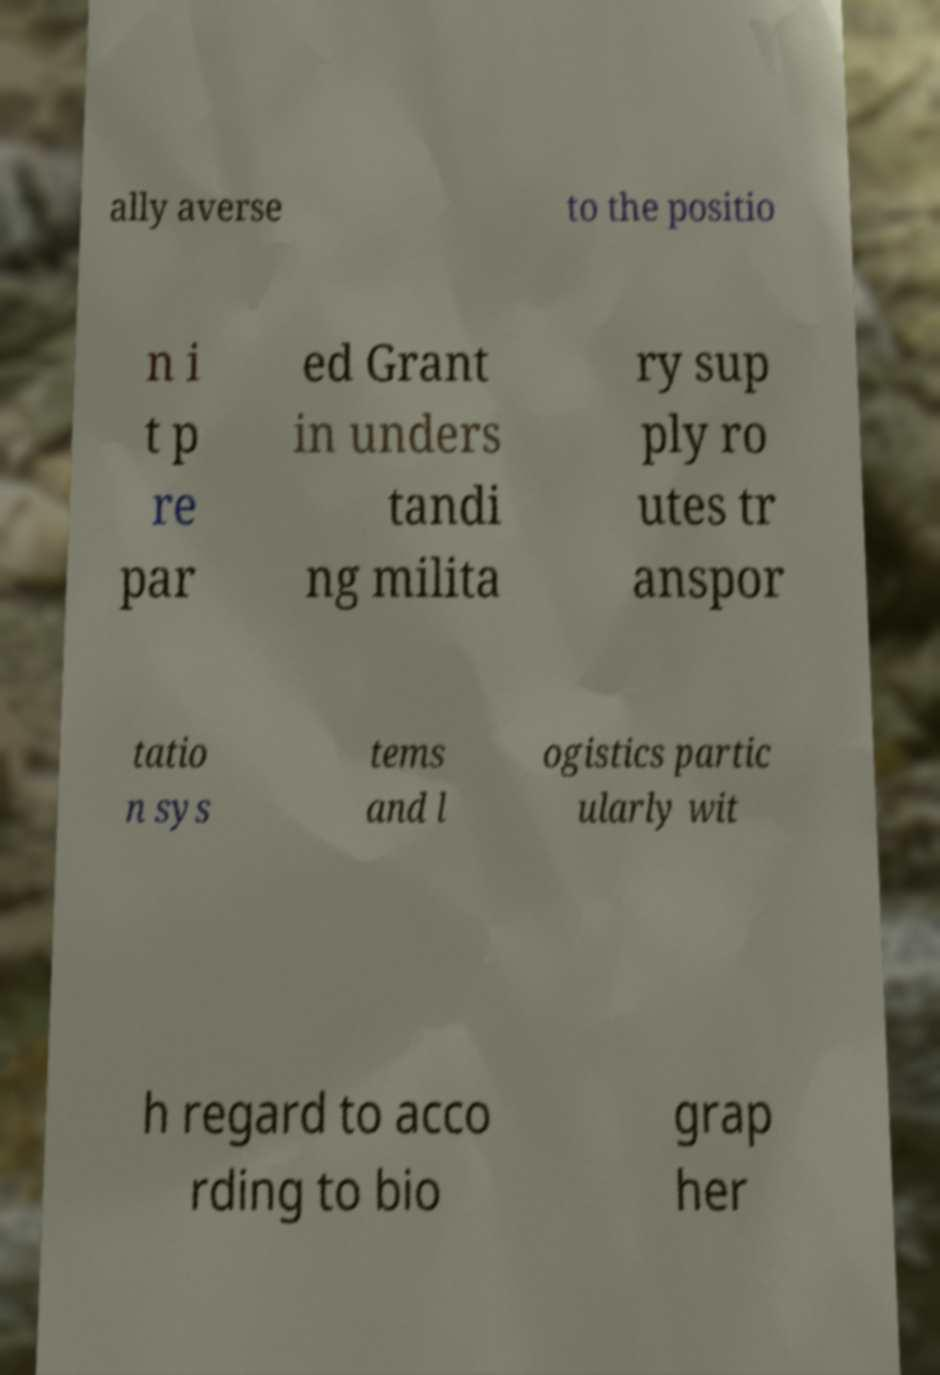Could you assist in decoding the text presented in this image and type it out clearly? ally averse to the positio n i t p re par ed Grant in unders tandi ng milita ry sup ply ro utes tr anspor tatio n sys tems and l ogistics partic ularly wit h regard to acco rding to bio grap her 